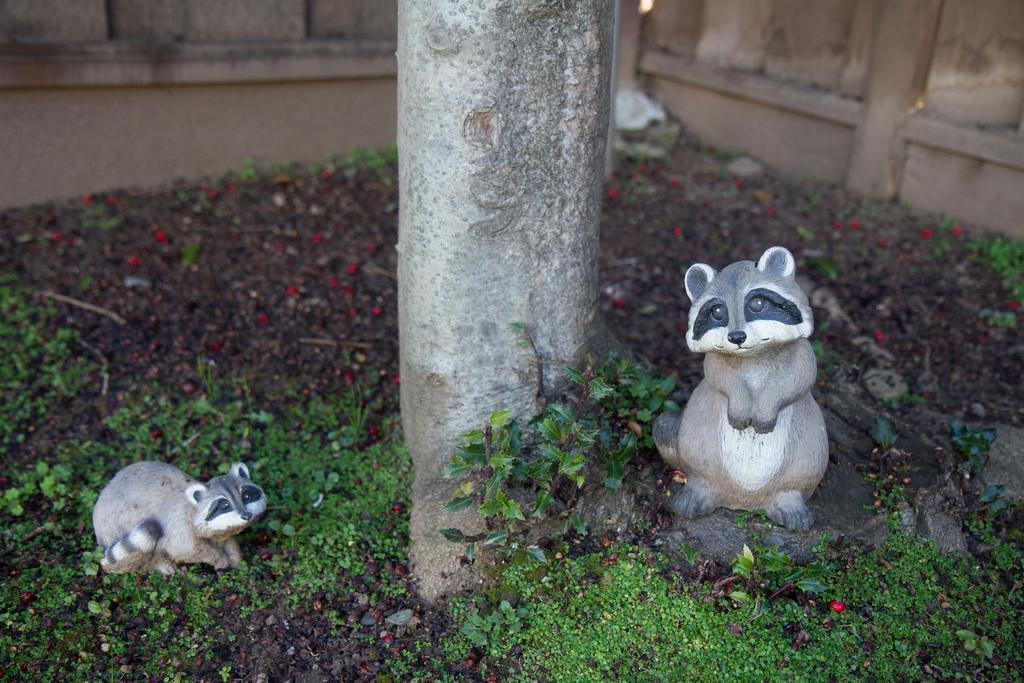In one or two sentences, can you explain what this image depicts? At the bottom of the image on the ground there are leaves and also there are red color things. There are two statues of an animal. In the middle of the image there is a tree trunk. In the background there is a fencing wall. 